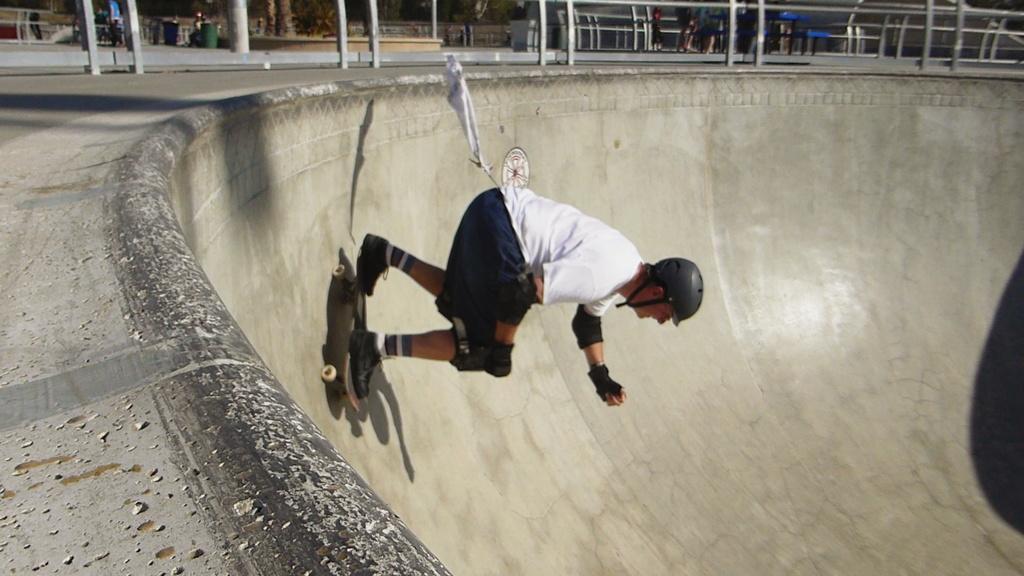Can you describe this image briefly? In this image a man with skating board, skating in a skating park, around the park there is fencing. 